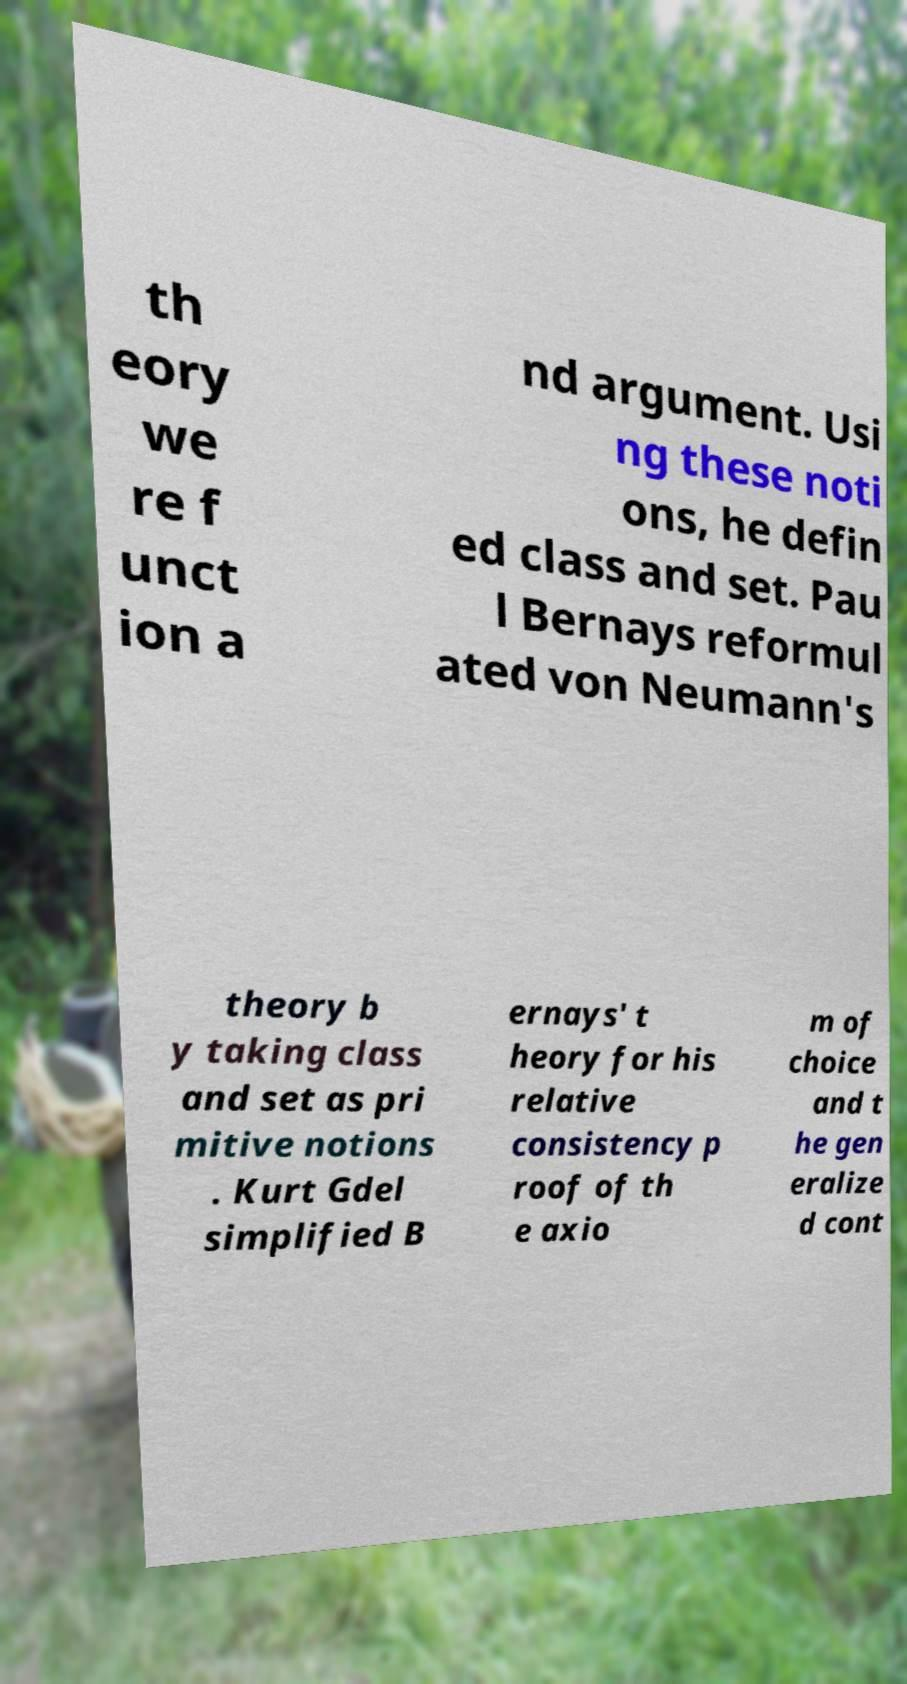What messages or text are displayed in this image? I need them in a readable, typed format. th eory we re f unct ion a nd argument. Usi ng these noti ons, he defin ed class and set. Pau l Bernays reformul ated von Neumann's theory b y taking class and set as pri mitive notions . Kurt Gdel simplified B ernays' t heory for his relative consistency p roof of th e axio m of choice and t he gen eralize d cont 